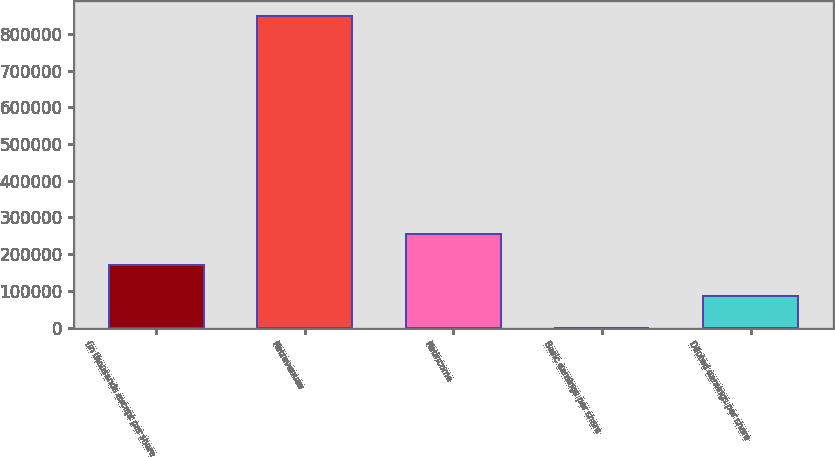Convert chart. <chart><loc_0><loc_0><loc_500><loc_500><bar_chart><fcel>(in thousands except per share<fcel>Netrevenues<fcel>Netincome<fcel>Basic earnings per share<fcel>Diluted earnings per share<nl><fcel>169610<fcel>848051<fcel>254415<fcel>0.05<fcel>84805.1<nl></chart> 